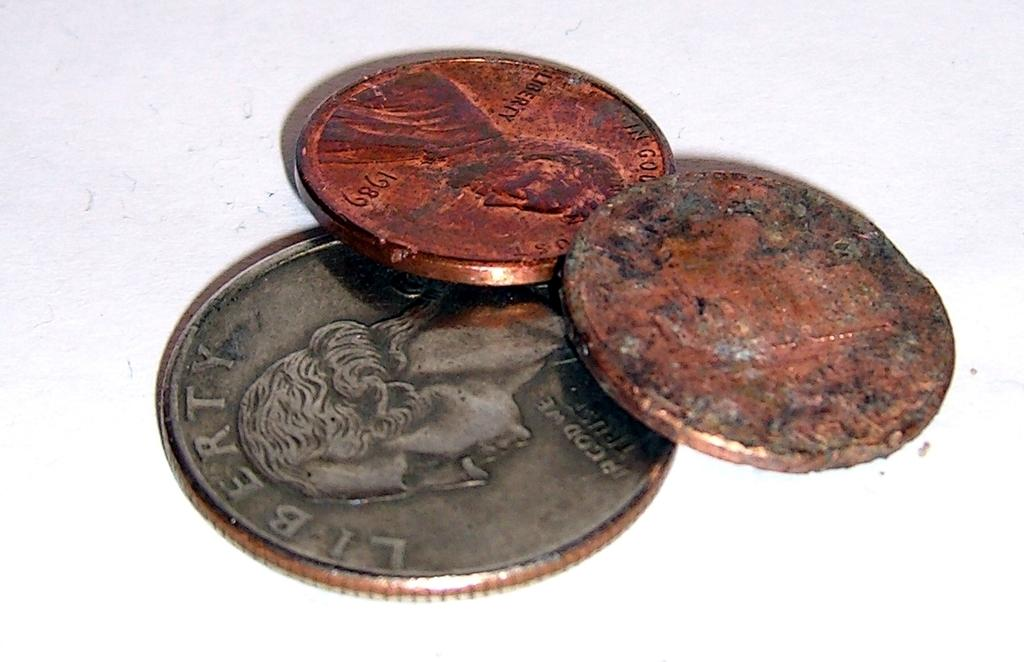How many coins are visible in the image? There are three coins in the image. What can be found on the surface of the coins? The coins have text and figures on them. What is the color of the surface on which the coins are placed? The coins are placed on a white surface. What type of tooth can be seen in the image? There is no tooth present in the image; it features three coins with text and figures on them. How does the zebra interact with the coins in the image? There is no zebra present in the image, so it cannot interact with the coins. 